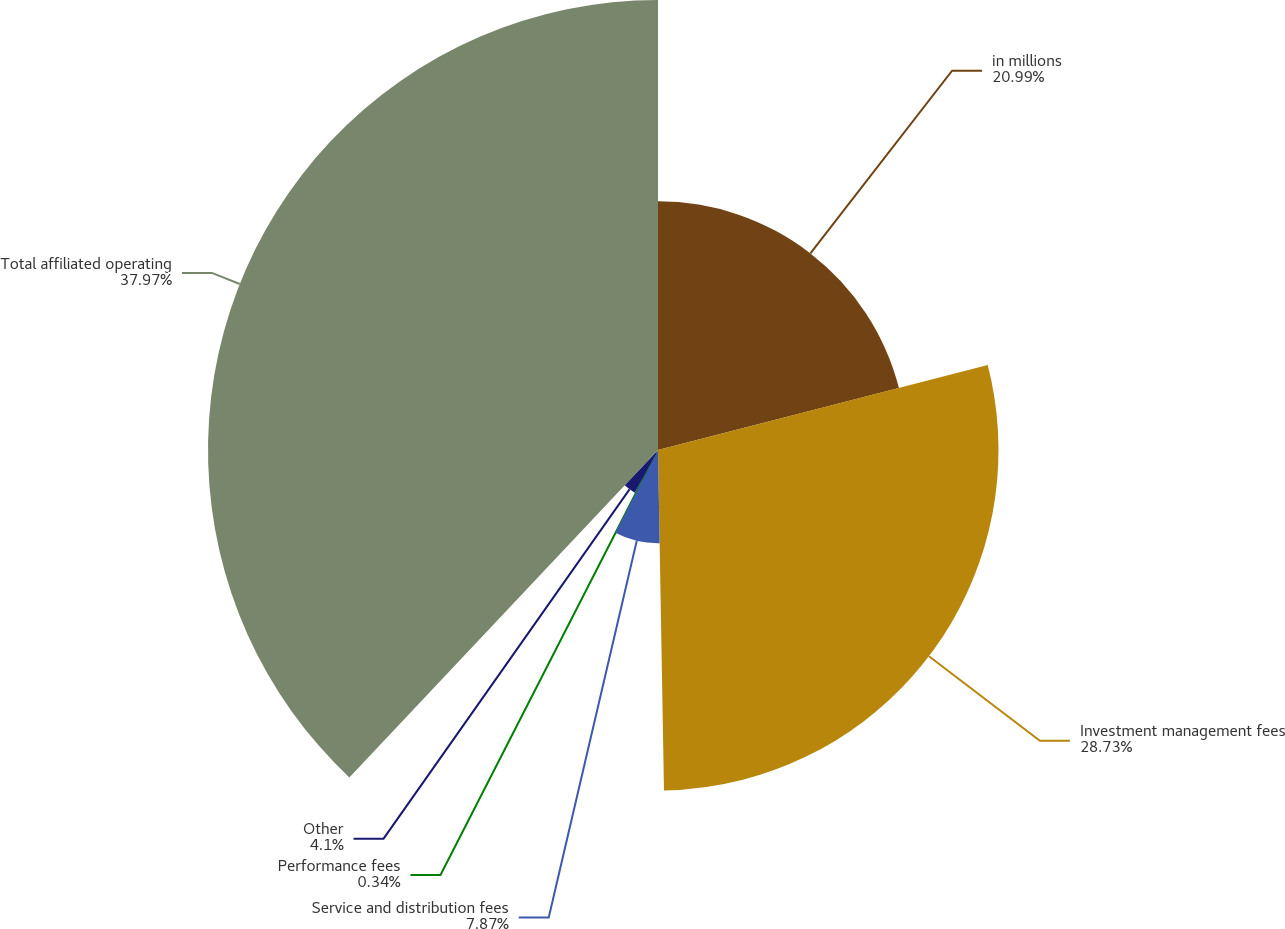Convert chart. <chart><loc_0><loc_0><loc_500><loc_500><pie_chart><fcel>in millions<fcel>Investment management fees<fcel>Service and distribution fees<fcel>Performance fees<fcel>Other<fcel>Total affiliated operating<nl><fcel>20.99%<fcel>28.73%<fcel>7.87%<fcel>0.34%<fcel>4.1%<fcel>37.97%<nl></chart> 